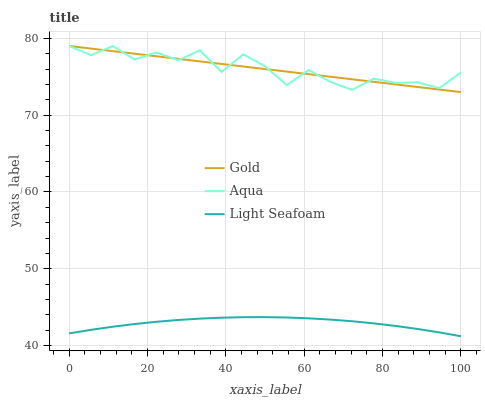Does Gold have the minimum area under the curve?
Answer yes or no. No. Does Gold have the maximum area under the curve?
Answer yes or no. No. Is Aqua the smoothest?
Answer yes or no. No. Is Gold the roughest?
Answer yes or no. No. Does Gold have the lowest value?
Answer yes or no. No. Is Light Seafoam less than Aqua?
Answer yes or no. Yes. Is Gold greater than Light Seafoam?
Answer yes or no. Yes. Does Light Seafoam intersect Aqua?
Answer yes or no. No. 